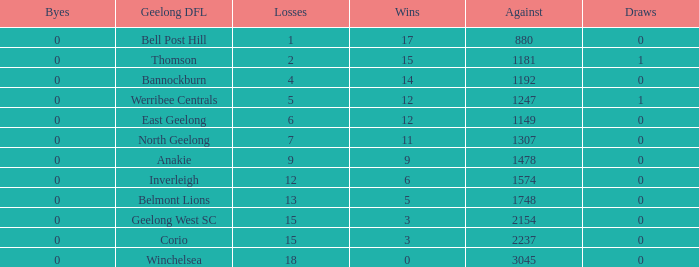What is the average of wins when the byes are less than 0? None. Would you mind parsing the complete table? {'header': ['Byes', 'Geelong DFL', 'Losses', 'Wins', 'Against', 'Draws'], 'rows': [['0', 'Bell Post Hill', '1', '17', '880', '0'], ['0', 'Thomson', '2', '15', '1181', '1'], ['0', 'Bannockburn', '4', '14', '1192', '0'], ['0', 'Werribee Centrals', '5', '12', '1247', '1'], ['0', 'East Geelong', '6', '12', '1149', '0'], ['0', 'North Geelong', '7', '11', '1307', '0'], ['0', 'Anakie', '9', '9', '1478', '0'], ['0', 'Inverleigh', '12', '6', '1574', '0'], ['0', 'Belmont Lions', '13', '5', '1748', '0'], ['0', 'Geelong West SC', '15', '3', '2154', '0'], ['0', 'Corio', '15', '3', '2237', '0'], ['0', 'Winchelsea', '18', '0', '3045', '0']]} 